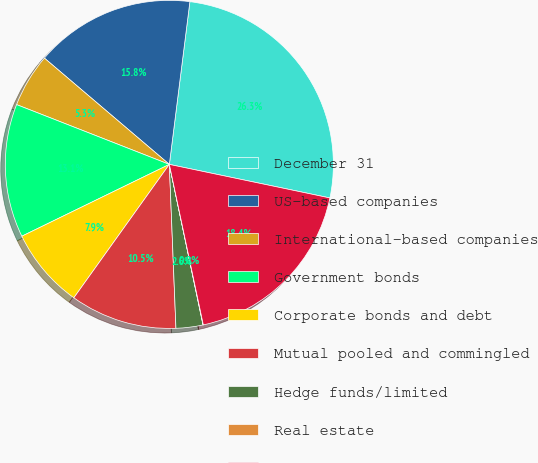Convert chart to OTSL. <chart><loc_0><loc_0><loc_500><loc_500><pie_chart><fcel>December 31<fcel>US-based companies<fcel>International-based companies<fcel>Government bonds<fcel>Corporate bonds and debt<fcel>Mutual pooled and commingled<fcel>Hedge funds/limited<fcel>Real estate<fcel>Total other postretirement<nl><fcel>26.28%<fcel>15.78%<fcel>5.28%<fcel>13.15%<fcel>7.9%<fcel>10.53%<fcel>2.65%<fcel>0.03%<fcel>18.4%<nl></chart> 